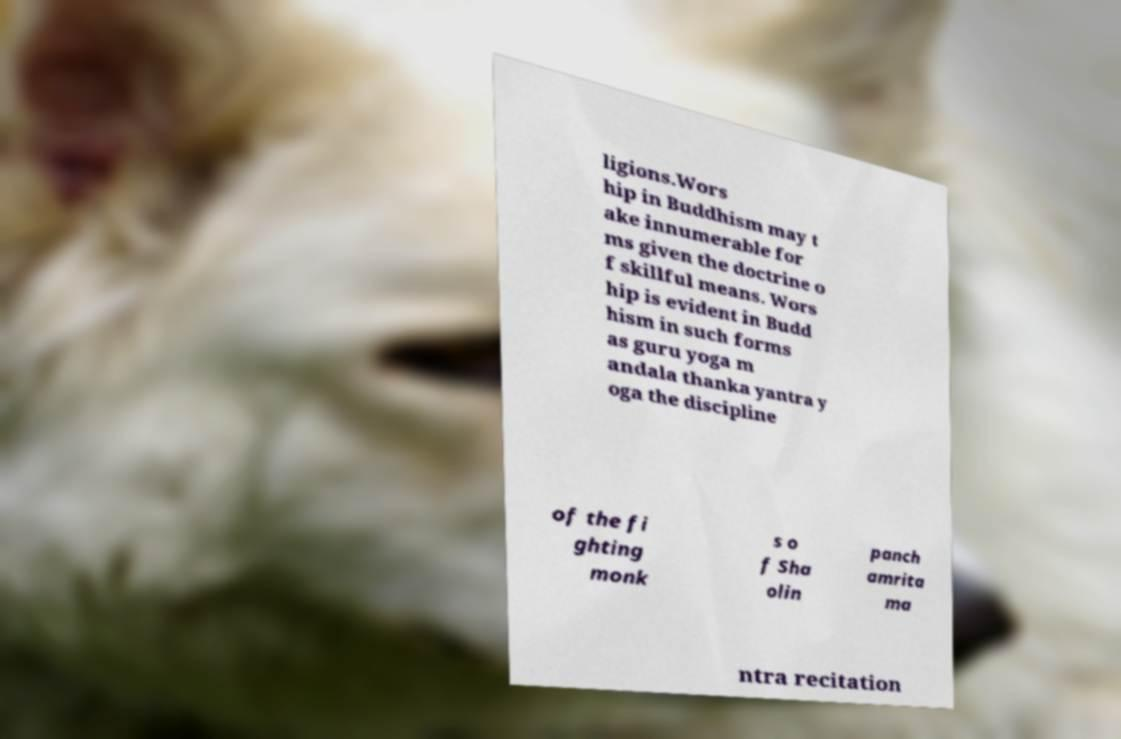I need the written content from this picture converted into text. Can you do that? ligions.Wors hip in Buddhism may t ake innumerable for ms given the doctrine o f skillful means. Wors hip is evident in Budd hism in such forms as guru yoga m andala thanka yantra y oga the discipline of the fi ghting monk s o f Sha olin panch amrita ma ntra recitation 